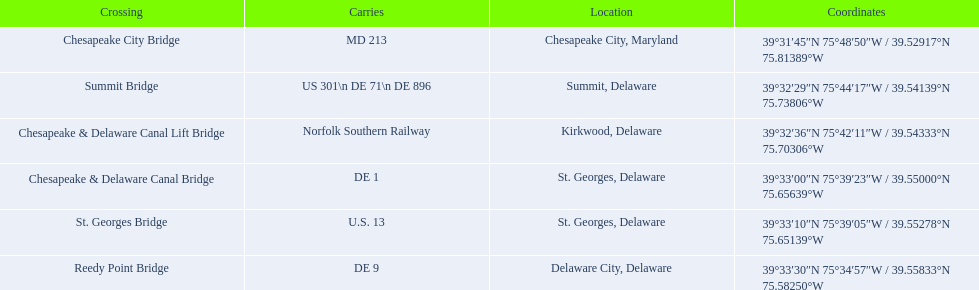What is the number of crossings in maryland? 1. 